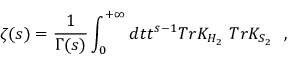Convert formula to latex. <formula><loc_0><loc_0><loc_500><loc_500>\zeta ( s ) = { \frac { 1 } { \Gamma ( s ) } } \int _ { 0 } ^ { + \infty } d t t ^ { s - 1 } T r K _ { H _ { 2 } } T r K _ { S _ { 2 } } ,</formula> 